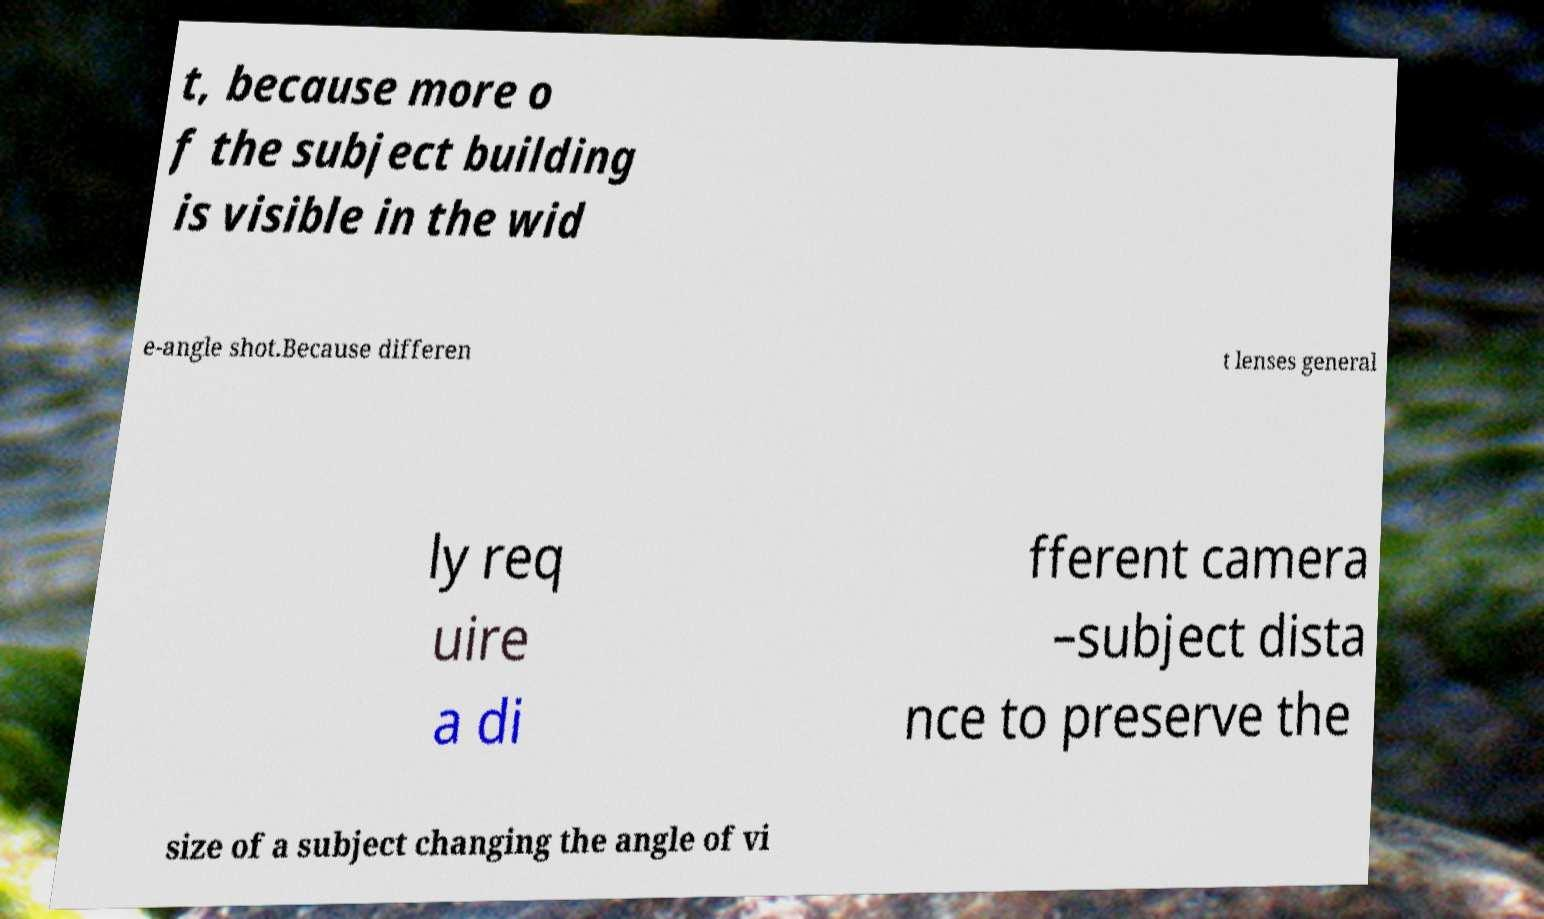What messages or text are displayed in this image? I need them in a readable, typed format. t, because more o f the subject building is visible in the wid e-angle shot.Because differen t lenses general ly req uire a di fferent camera –subject dista nce to preserve the size of a subject changing the angle of vi 